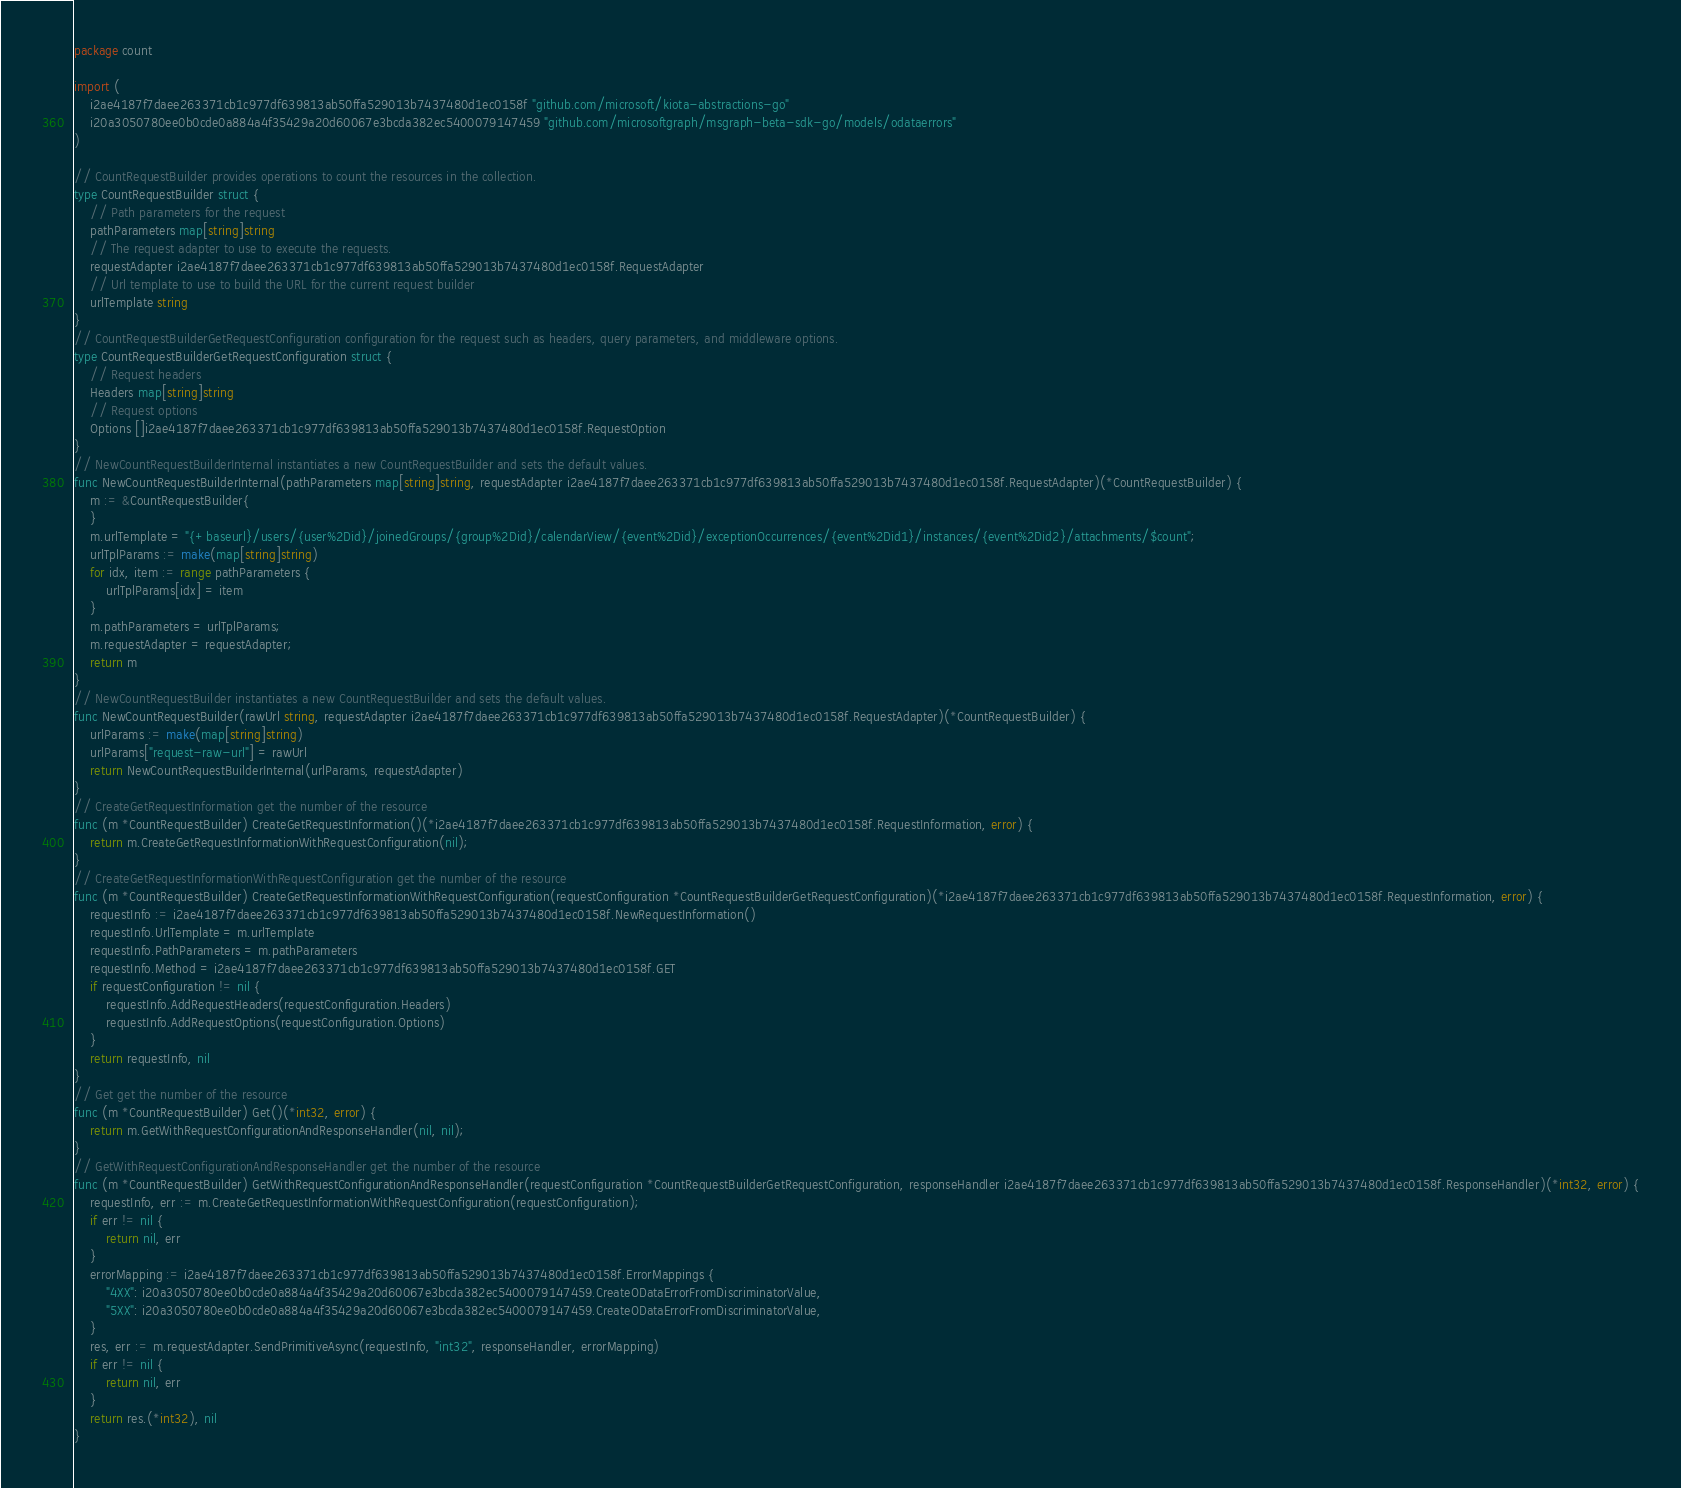Convert code to text. <code><loc_0><loc_0><loc_500><loc_500><_Go_>package count

import (
    i2ae4187f7daee263371cb1c977df639813ab50ffa529013b7437480d1ec0158f "github.com/microsoft/kiota-abstractions-go"
    i20a3050780ee0b0cde0a884a4f35429a20d60067e3bcda382ec5400079147459 "github.com/microsoftgraph/msgraph-beta-sdk-go/models/odataerrors"
)

// CountRequestBuilder provides operations to count the resources in the collection.
type CountRequestBuilder struct {
    // Path parameters for the request
    pathParameters map[string]string
    // The request adapter to use to execute the requests.
    requestAdapter i2ae4187f7daee263371cb1c977df639813ab50ffa529013b7437480d1ec0158f.RequestAdapter
    // Url template to use to build the URL for the current request builder
    urlTemplate string
}
// CountRequestBuilderGetRequestConfiguration configuration for the request such as headers, query parameters, and middleware options.
type CountRequestBuilderGetRequestConfiguration struct {
    // Request headers
    Headers map[string]string
    // Request options
    Options []i2ae4187f7daee263371cb1c977df639813ab50ffa529013b7437480d1ec0158f.RequestOption
}
// NewCountRequestBuilderInternal instantiates a new CountRequestBuilder and sets the default values.
func NewCountRequestBuilderInternal(pathParameters map[string]string, requestAdapter i2ae4187f7daee263371cb1c977df639813ab50ffa529013b7437480d1ec0158f.RequestAdapter)(*CountRequestBuilder) {
    m := &CountRequestBuilder{
    }
    m.urlTemplate = "{+baseurl}/users/{user%2Did}/joinedGroups/{group%2Did}/calendarView/{event%2Did}/exceptionOccurrences/{event%2Did1}/instances/{event%2Did2}/attachments/$count";
    urlTplParams := make(map[string]string)
    for idx, item := range pathParameters {
        urlTplParams[idx] = item
    }
    m.pathParameters = urlTplParams;
    m.requestAdapter = requestAdapter;
    return m
}
// NewCountRequestBuilder instantiates a new CountRequestBuilder and sets the default values.
func NewCountRequestBuilder(rawUrl string, requestAdapter i2ae4187f7daee263371cb1c977df639813ab50ffa529013b7437480d1ec0158f.RequestAdapter)(*CountRequestBuilder) {
    urlParams := make(map[string]string)
    urlParams["request-raw-url"] = rawUrl
    return NewCountRequestBuilderInternal(urlParams, requestAdapter)
}
// CreateGetRequestInformation get the number of the resource
func (m *CountRequestBuilder) CreateGetRequestInformation()(*i2ae4187f7daee263371cb1c977df639813ab50ffa529013b7437480d1ec0158f.RequestInformation, error) {
    return m.CreateGetRequestInformationWithRequestConfiguration(nil);
}
// CreateGetRequestInformationWithRequestConfiguration get the number of the resource
func (m *CountRequestBuilder) CreateGetRequestInformationWithRequestConfiguration(requestConfiguration *CountRequestBuilderGetRequestConfiguration)(*i2ae4187f7daee263371cb1c977df639813ab50ffa529013b7437480d1ec0158f.RequestInformation, error) {
    requestInfo := i2ae4187f7daee263371cb1c977df639813ab50ffa529013b7437480d1ec0158f.NewRequestInformation()
    requestInfo.UrlTemplate = m.urlTemplate
    requestInfo.PathParameters = m.pathParameters
    requestInfo.Method = i2ae4187f7daee263371cb1c977df639813ab50ffa529013b7437480d1ec0158f.GET
    if requestConfiguration != nil {
        requestInfo.AddRequestHeaders(requestConfiguration.Headers)
        requestInfo.AddRequestOptions(requestConfiguration.Options)
    }
    return requestInfo, nil
}
// Get get the number of the resource
func (m *CountRequestBuilder) Get()(*int32, error) {
    return m.GetWithRequestConfigurationAndResponseHandler(nil, nil);
}
// GetWithRequestConfigurationAndResponseHandler get the number of the resource
func (m *CountRequestBuilder) GetWithRequestConfigurationAndResponseHandler(requestConfiguration *CountRequestBuilderGetRequestConfiguration, responseHandler i2ae4187f7daee263371cb1c977df639813ab50ffa529013b7437480d1ec0158f.ResponseHandler)(*int32, error) {
    requestInfo, err := m.CreateGetRequestInformationWithRequestConfiguration(requestConfiguration);
    if err != nil {
        return nil, err
    }
    errorMapping := i2ae4187f7daee263371cb1c977df639813ab50ffa529013b7437480d1ec0158f.ErrorMappings {
        "4XX": i20a3050780ee0b0cde0a884a4f35429a20d60067e3bcda382ec5400079147459.CreateODataErrorFromDiscriminatorValue,
        "5XX": i20a3050780ee0b0cde0a884a4f35429a20d60067e3bcda382ec5400079147459.CreateODataErrorFromDiscriminatorValue,
    }
    res, err := m.requestAdapter.SendPrimitiveAsync(requestInfo, "int32", responseHandler, errorMapping)
    if err != nil {
        return nil, err
    }
    return res.(*int32), nil
}
</code> 